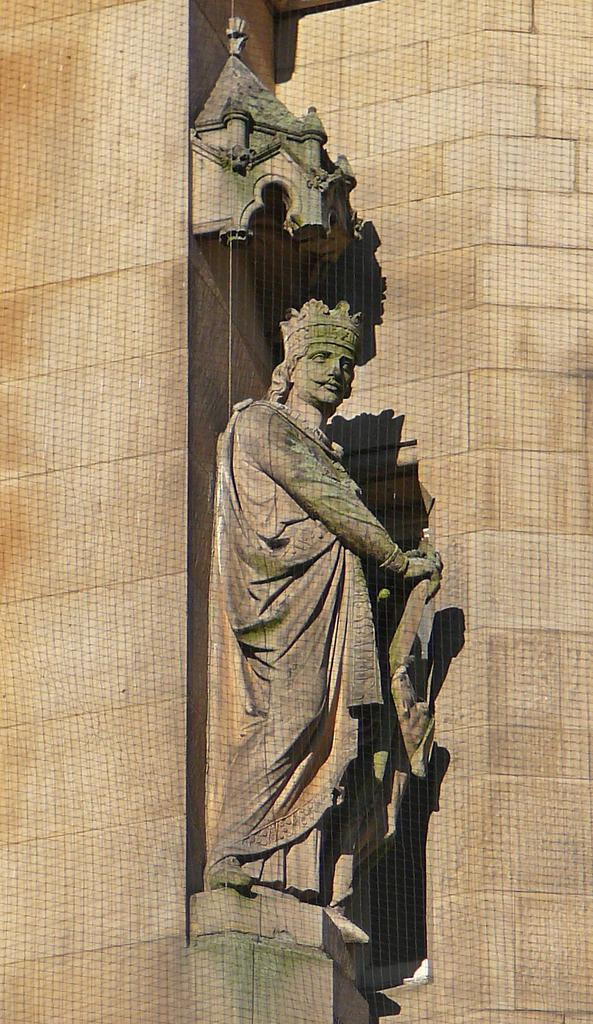What is the main subject of the image? There is a sculpture of a man in the image. What can be seen in the background of the image? There is a wall in the image. How many holes can be seen in the sculpture of the man in the image? There are no holes visible in the sculpture of the man in the image. What type of kitty is sitting on the wall in the image? There is no kitty present in the image; it only features a sculpture of a man and a wall. 